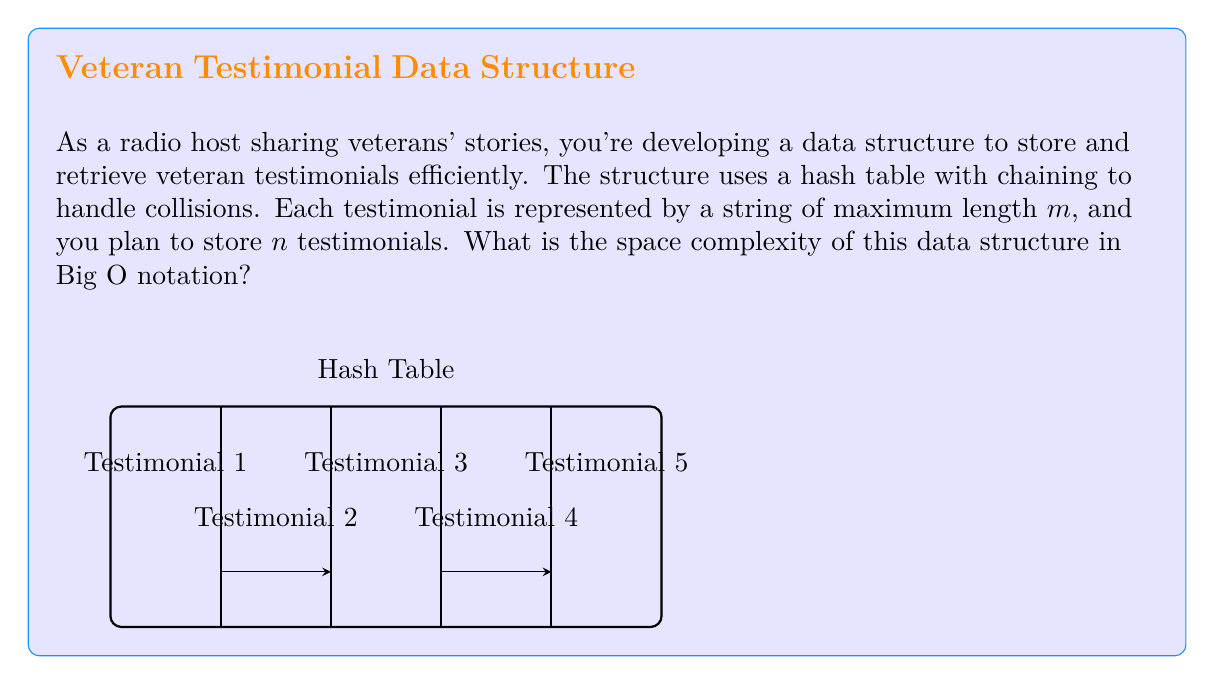Help me with this question. Let's break down the space complexity analysis step-by-step:

1) Hash Table Structure:
   - The hash table itself requires $O(n)$ space, where $n$ is the number of buckets (usually proportional to the number of testimonials).

2) Testimonial Storage:
   - Each testimonial is a string of maximum length $m$.
   - The space required for each testimonial is $O(m)$.
   - There are $n$ testimonials in total.
   - Total space for testimonials: $O(n \cdot m)$

3) Chaining for Collision Handling:
   - In the worst case, all testimonials could hash to the same bucket.
   - This would result in a linked list of length $n$.
   - The space for pointers in the linked list is $O(n)$.

4) Combining the Components:
   - Hash table structure: $O(n)$
   - Testimonial storage: $O(n \cdot m)$
   - Chaining pointers: $O(n)$

5) Total Space Complexity:
   $$O(n) + O(n \cdot m) + O(n) = O(n \cdot m)$$

The term $O(n \cdot m)$ dominates, as it's larger than $O(n)$ for any $m > 1$.

Therefore, the overall space complexity is $O(n \cdot m)$, where $n$ is the number of testimonials and $m$ is the maximum length of each testimonial.
Answer: $O(n \cdot m)$ 